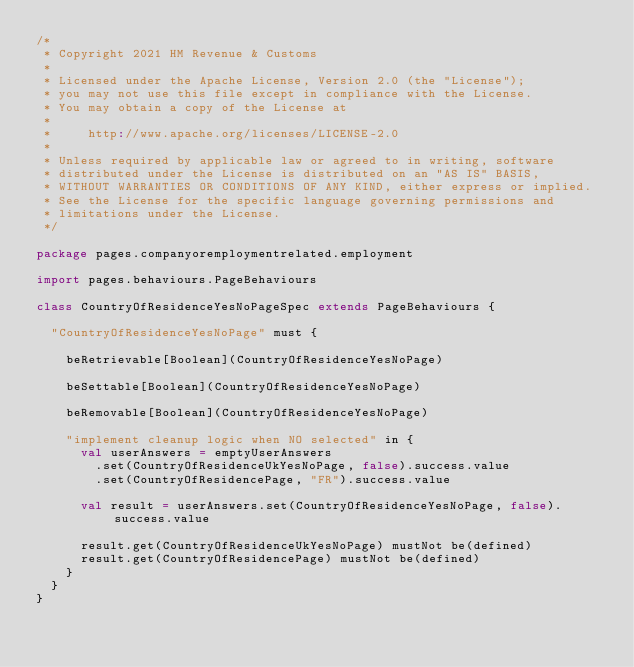Convert code to text. <code><loc_0><loc_0><loc_500><loc_500><_Scala_>/*
 * Copyright 2021 HM Revenue & Customs
 *
 * Licensed under the Apache License, Version 2.0 (the "License");
 * you may not use this file except in compliance with the License.
 * You may obtain a copy of the License at
 *
 *     http://www.apache.org/licenses/LICENSE-2.0
 *
 * Unless required by applicable law or agreed to in writing, software
 * distributed under the License is distributed on an "AS IS" BASIS,
 * WITHOUT WARRANTIES OR CONDITIONS OF ANY KIND, either express or implied.
 * See the License for the specific language governing permissions and
 * limitations under the License.
 */

package pages.companyoremploymentrelated.employment

import pages.behaviours.PageBehaviours

class CountryOfResidenceYesNoPageSpec extends PageBehaviours {

  "CountryOfResidenceYesNoPage" must {

    beRetrievable[Boolean](CountryOfResidenceYesNoPage)

    beSettable[Boolean](CountryOfResidenceYesNoPage)

    beRemovable[Boolean](CountryOfResidenceYesNoPage)

    "implement cleanup logic when NO selected" in {
      val userAnswers = emptyUserAnswers
        .set(CountryOfResidenceUkYesNoPage, false).success.value
        .set(CountryOfResidencePage, "FR").success.value

      val result = userAnswers.set(CountryOfResidenceYesNoPage, false).success.value

      result.get(CountryOfResidenceUkYesNoPage) mustNot be(defined)
      result.get(CountryOfResidencePage) mustNot be(defined)
    }
  }
}
</code> 